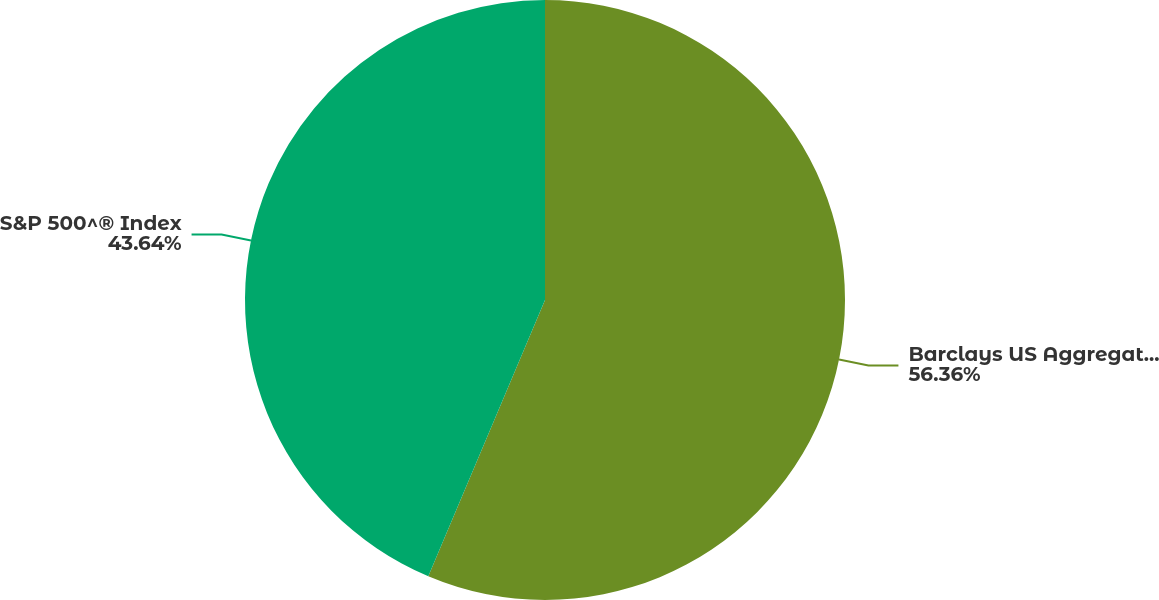Convert chart. <chart><loc_0><loc_0><loc_500><loc_500><pie_chart><fcel>Barclays US Aggregate Bond<fcel>S&P 500^® Index<nl><fcel>56.36%<fcel>43.64%<nl></chart> 